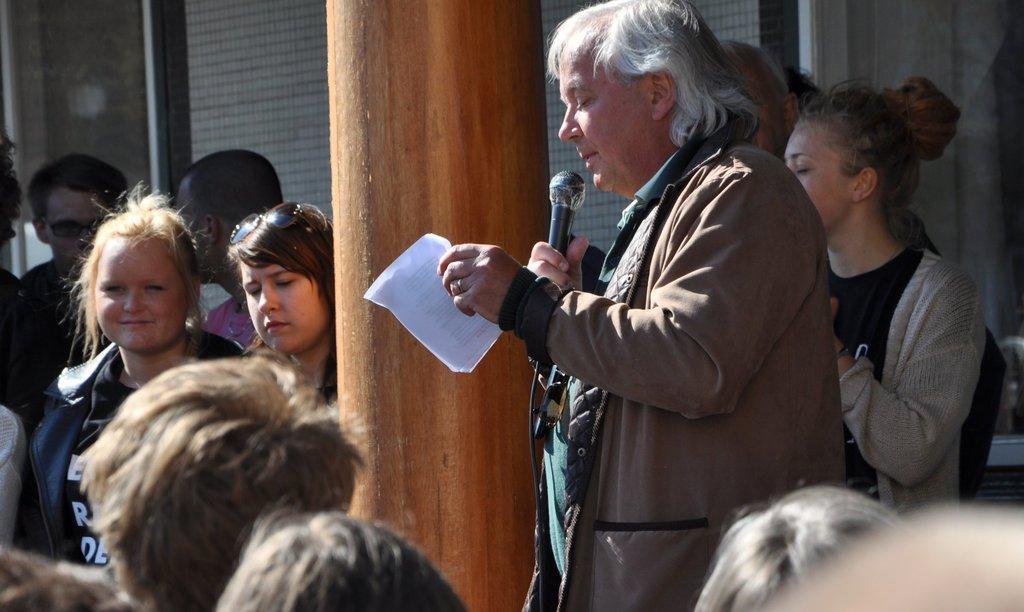Describe this image in one or two sentences. In this image there are a few people standing, in between them there is a person standing and holding a mic in one hand and papers in the other hand, beside him there is a pillar and in the background there is a building. 